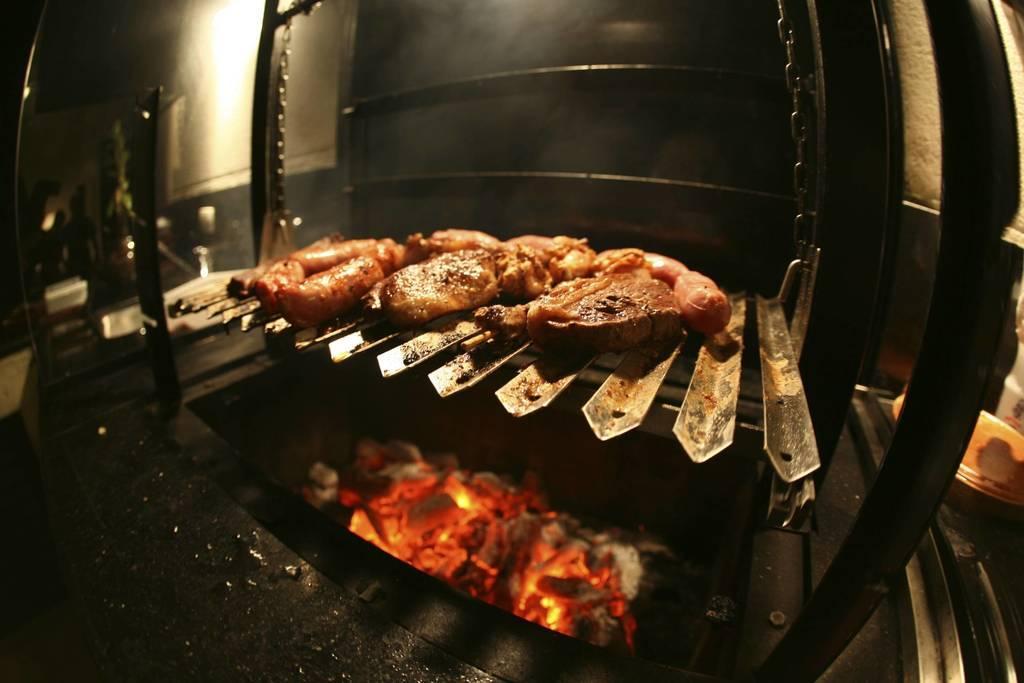Describe this image in one or two sentences. In this image I can see the food and the food is on the grill stove. I can also see the fire under the grills, background the wall is in white and black color. 